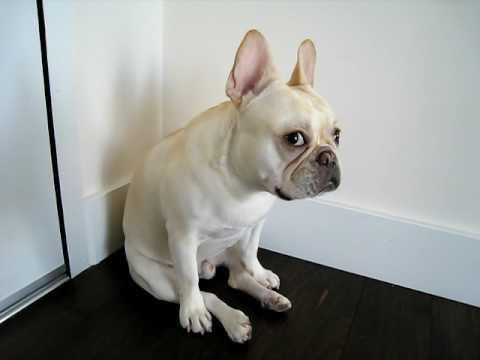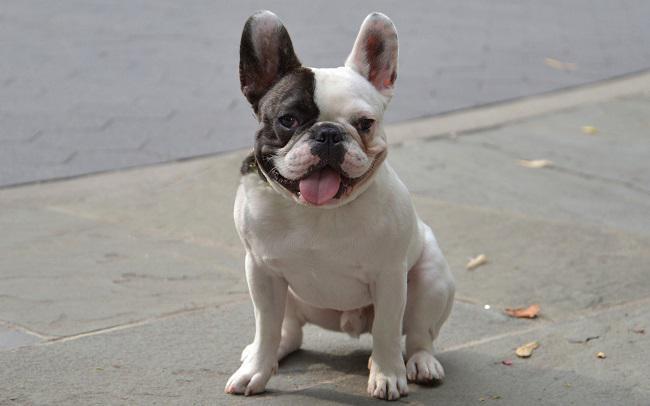The first image is the image on the left, the second image is the image on the right. Analyze the images presented: Is the assertion "One dog is indoors, and another is outdoors." valid? Answer yes or no. Yes. 